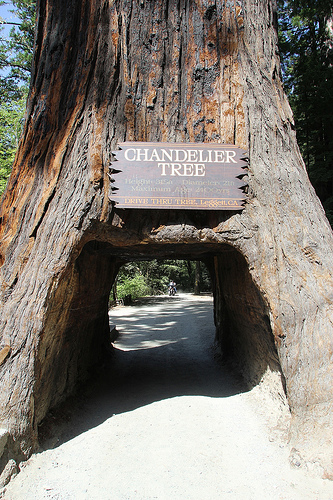<image>
Is there a road to the right of the tree? No. The road is not to the right of the tree. The horizontal positioning shows a different relationship. 